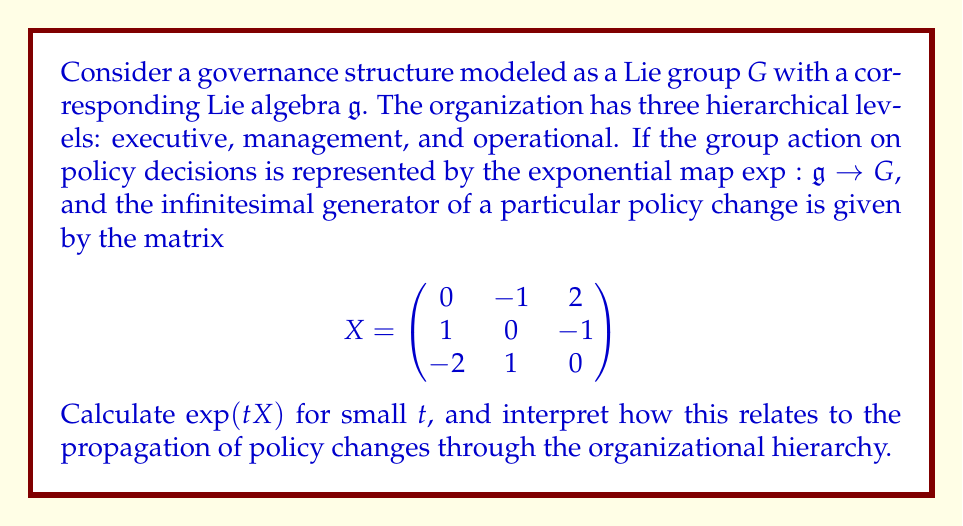Can you answer this question? To solve this problem, we need to follow these steps:

1) First, recall that for small $t$, the exponential map can be approximated by its Taylor series:

   $$\exp(tX) \approx I + tX + \frac{t^2}{2}X^2 + O(t^3)$$

   where $I$ is the identity matrix and $O(t^3)$ represents terms of order $t^3$ and higher.

2) We need to calculate $X^2$:

   $$X^2 = \begin{pmatrix}
   0 & -1 & 2 \\
   1 & 0 & -1 \\
   -2 & 1 & 0
   \end{pmatrix} \begin{pmatrix}
   0 & -1 & 2 \\
   1 & 0 & -1 \\
   -2 & 1 & 0
   \end{pmatrix} = \begin{pmatrix}
   -5 & 0 & 1 \\
   0 & -5 & 0 \\
   1 & 0 & -5
   \end{pmatrix}$$

3) Now we can substitute these into our approximation:

   $$\exp(tX) \approx \begin{pmatrix}
   1 & 0 & 0 \\
   0 & 1 & 0 \\
   0 & 0 & 1
   \end{pmatrix} + t\begin{pmatrix}
   0 & -1 & 2 \\
   1 & 0 & -1 \\
   -2 & 1 & 0
   \end{pmatrix} + \frac{t^2}{2}\begin{pmatrix}
   -5 & 0 & 1 \\
   0 & -5 & 0 \\
   1 & 0 & -5
   \end{pmatrix}$$

4) Simplifying:

   $$\exp(tX) \approx \begin{pmatrix}
   1-\frac{5t^2}{2} & -t & 2t+\frac{t^2}{2} \\
   t & 1-\frac{5t^2}{2} & -t \\
   -2t+\frac{t^2}{2} & t & 1-\frac{5t^2}{2}
   \end{pmatrix}$$

Interpretation:
The matrix $\exp(tX)$ represents how a small policy change propagates through the organization over time $t$. The rows and columns correspond to the three hierarchical levels (executive, management, operational).

- The diagonal elements $(1-\frac{5t^2}{2})$ show that each level experiences a similar quadratic decrease in its initial state, indicating a uniform impact across levels.
- The off-diagonal elements show how each level influences the others:
  - The executive level (1st row/column) has a strong positive influence on the operational level (2t) and a negative influence on the management level (-t).
  - The management level (2nd row/column) has equal but opposite influences on the executive and operational levels (t and -t).
  - The operational level (3rd row/column) has a strong negative influence on the executive level (-2t) and a positive influence on the management level (t).

This structure suggests a cyclical flow of influence, where policy changes create a feedback loop through the organizational hierarchy.
Answer: $$\exp(tX) \approx \begin{pmatrix}
1-\frac{5t^2}{2} & -t & 2t+\frac{t^2}{2} \\
t & 1-\frac{5t^2}{2} & -t \\
-2t+\frac{t^2}{2} & t & 1-\frac{5t^2}{2}
\end{pmatrix}$$ 